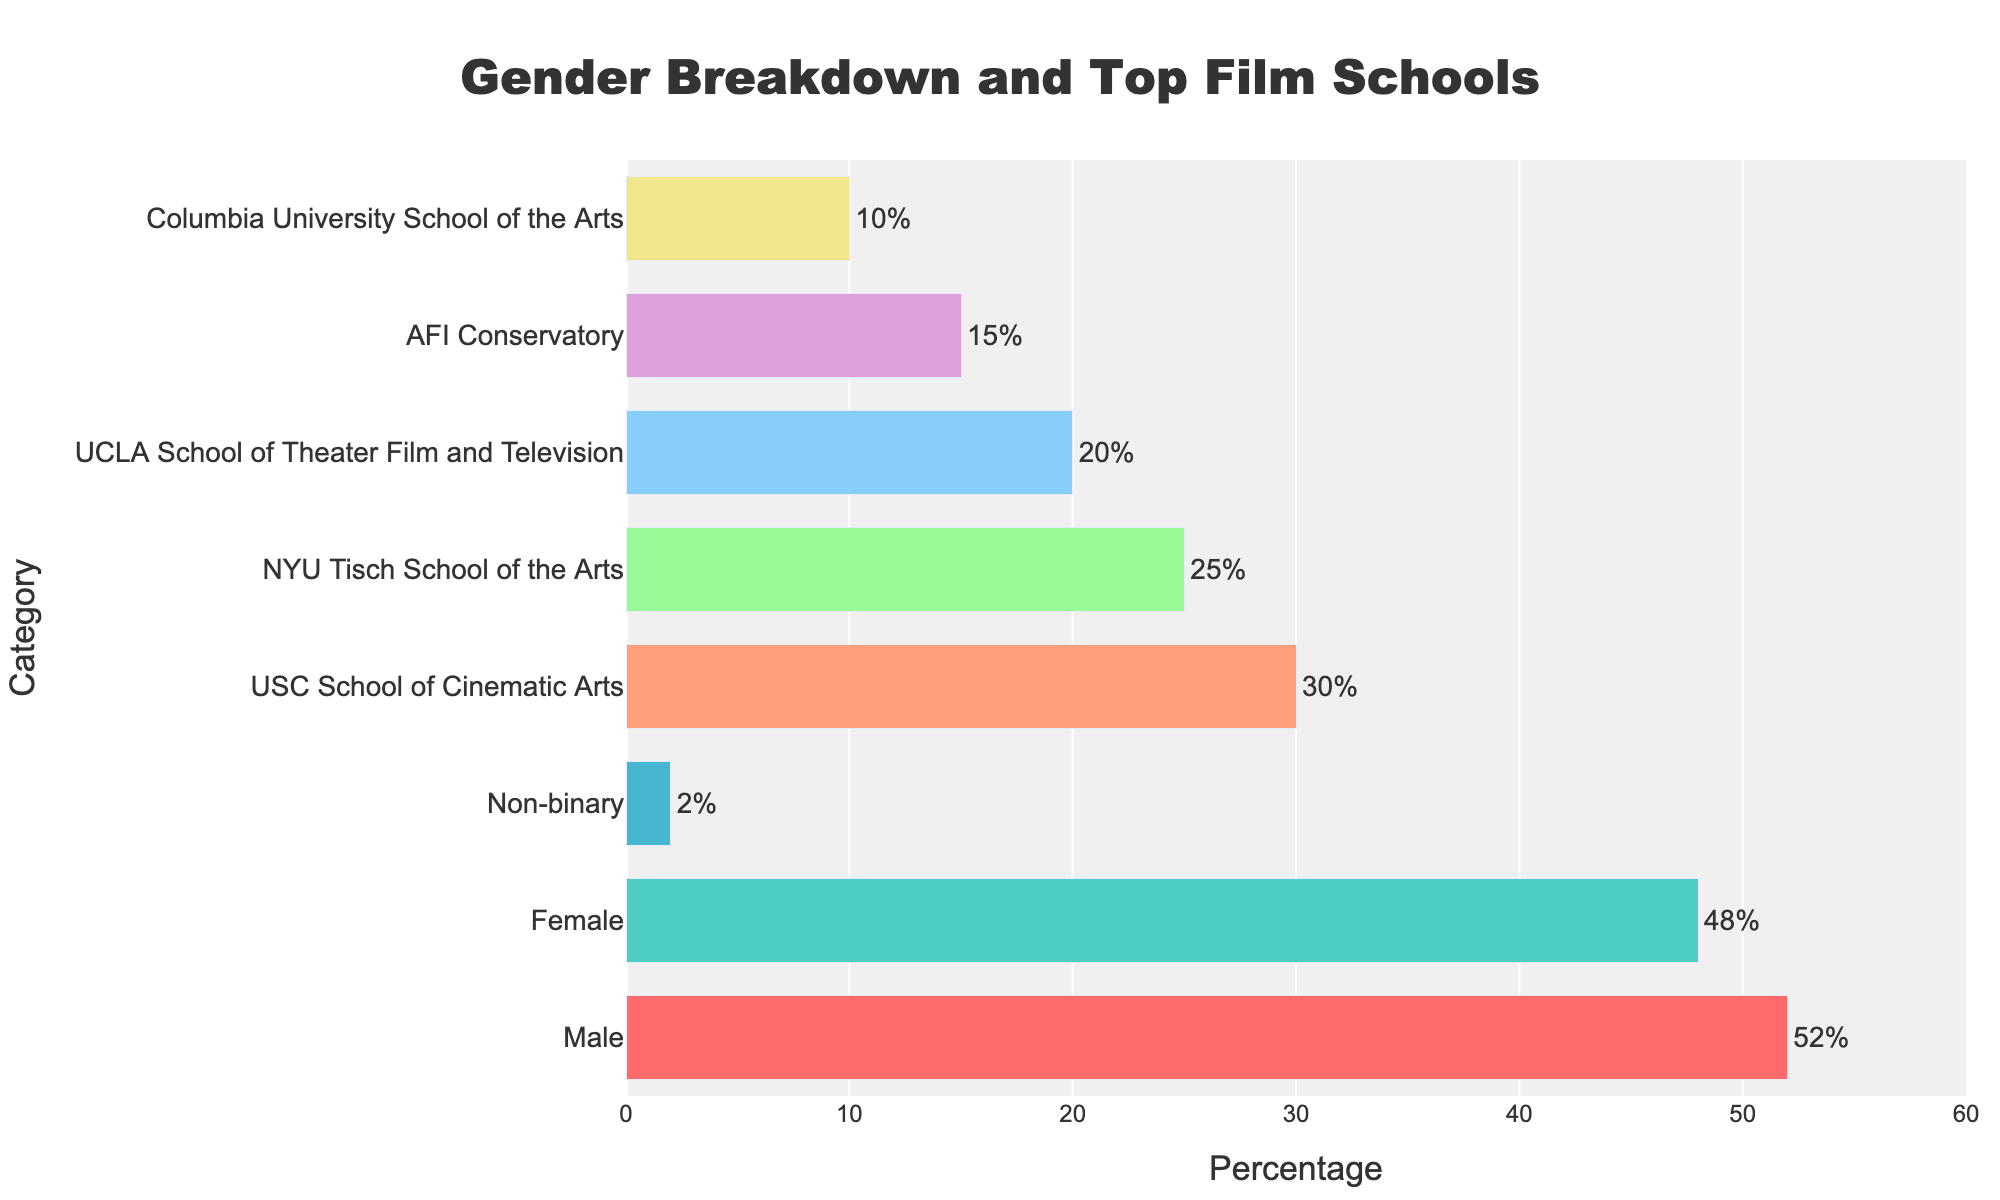What's the overall theme of the figure? The figure presents the gender breakdown and top US film schools attended by film school graduates, showing proportions for different genders and the percentage of graduates from various schools.
Answer: Gender breakdown and top film schools for film school graduates Which gender has the highest percentage of graduates? The figure shows different bar lengths for each gender, and the longest bar corresponds to 'Male' with a percentage of 52%.
Answer: Male What is the percentage of Non-binary graduates? The figure includes a bar for 'Non-binary' under the gender breakdown category and the percentage is labeled beside it as 2%.
Answer: 2% How many categories are displayed in the y-axis? The y-axis contains a total of eight categories—three genders (Male, Female, Non-binary) and five film schools.
Answer: Eight Which film school has the second highest percentage of graduates? Among the film schools listed, the second longest bar belongs to 'NYU Tisch School of the Arts' with a percentage of 25%.
Answer: NYU Tisch School of the Arts What is the total percentage of graduates from USC and UCLA combined? Adding the percentages from the bars labeled 'USC School of Cinematic Arts' (30%) and 'UCLA School of Theater Film and Television' (20%) gives 30% + 20% = 50%.
Answer: 50% How does the percentage of female graduates compare to that of male graduates? By comparing the bars for 'Female' (48%) and 'Male' (52%), it is clear that there is a 4% difference, with male graduates having a slightly higher percentage.
Answer: Male graduates are 4% higher Which film school has the smallest percentage of graduates? The shortest bar under the film school category corresponds to 'Columbia University School of the Arts' with a percentage of 10%.
Answer: Columbia University School of the Arts What are the color schemes used for gender categories and for film schools? The gender categories use shades of red, teal, and blue, while the film schools use pastel colors like light salmon, light green, light blue, plum, and khaki.
Answer: Red/teal/blue for genders, pastel shades for film schools 